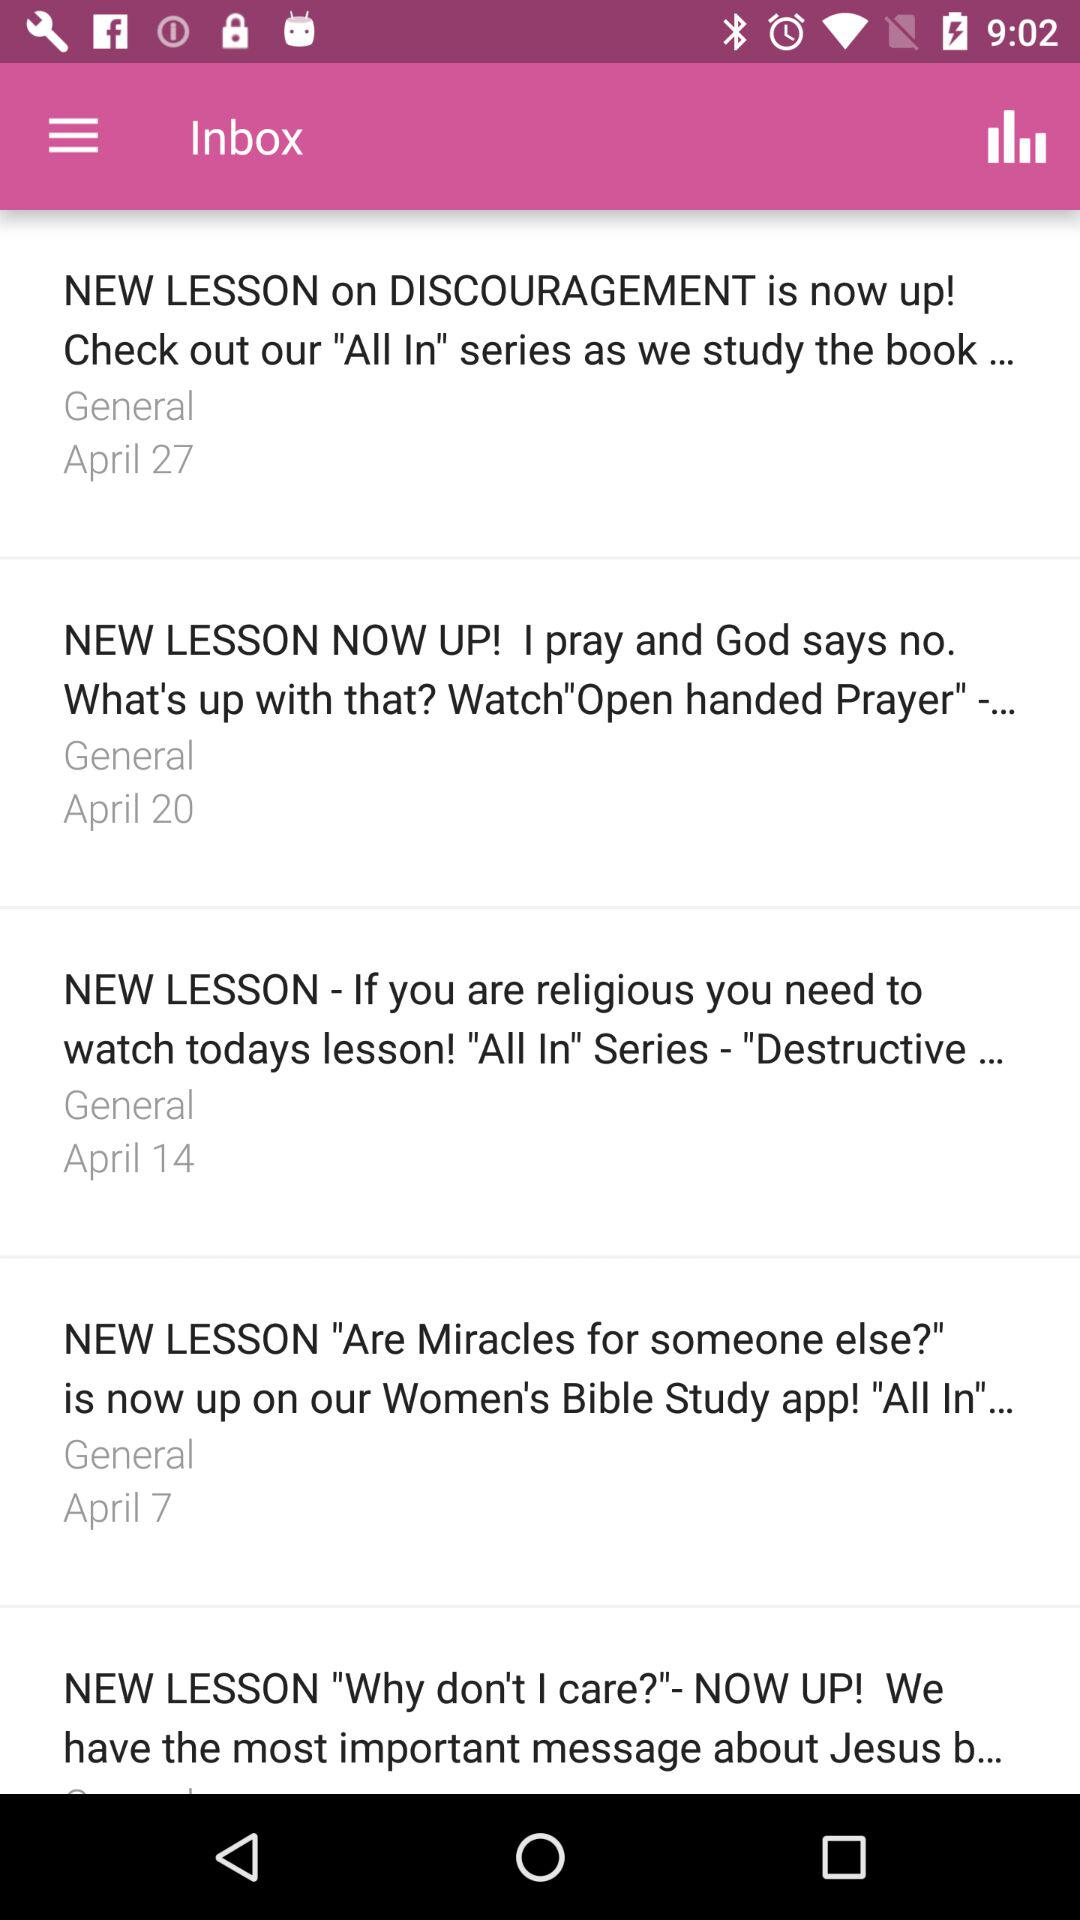On what date did the mail about the new lesson on discouragement arrive? The mail about the new lesson on discouragement arrived on April 27. 